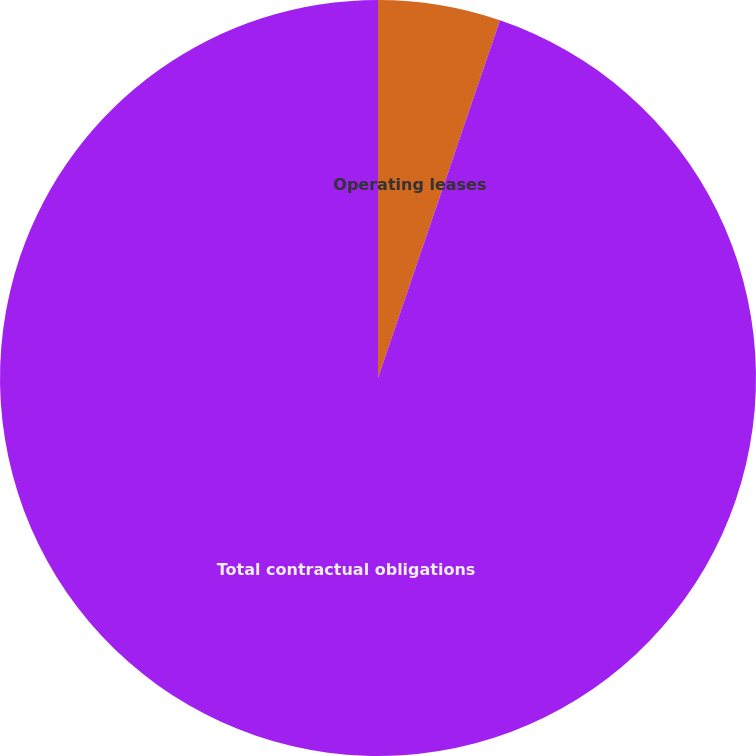<chart> <loc_0><loc_0><loc_500><loc_500><pie_chart><fcel>Operating leases<fcel>Total contractual obligations<nl><fcel>5.23%<fcel>94.77%<nl></chart> 